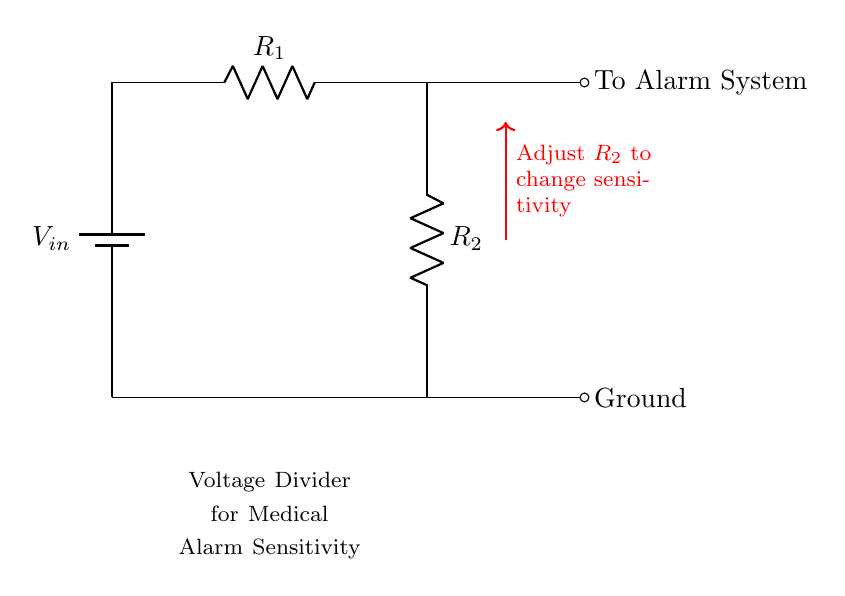What is the input voltage of the circuit? The input voltage, labeled as V_in, is the voltage supplied by the battery at the top of the circuit. It is usually a specified value in the schematic, commonly 5V or 12V.
Answer: V_in What do the resistors R_1 and R_2 represent? R_1 and R_2 are resistors in the voltage divider circuit. They determine the division of input voltage that will be fed into the alarm system, influencing sensitivity.
Answer: Resistors How does adjusting R_2 affect the output voltage? Adjusting R_2 changes the division of the input voltage between R_1 and R_2. Increasing R_2 decreases the output voltage to the alarm system, while decreasing R_2 increases it.
Answer: Changes output voltage What is the purpose of the voltage divider in this circuit? The voltage divider is used to adjust the sensitivity of the medical alarm system. It allows the system to react appropriately to various input conditions.
Answer: Adjust sensitivity How many terminals are connected to the alarm system? The alarm system has one terminal connected to the output of the voltage divider, receiving the adjusted voltage signal necessary for operation.
Answer: One terminal What is the voltage at the alarm system when R_1 and R_2 are equal? When R_1 and R_2 are equal, the output voltage at the alarm system is half of the input voltage, as the voltage divider formula states that V_out = V_in * (R_2 / (R_1 + R_2)).
Answer: Half of the input voltage 